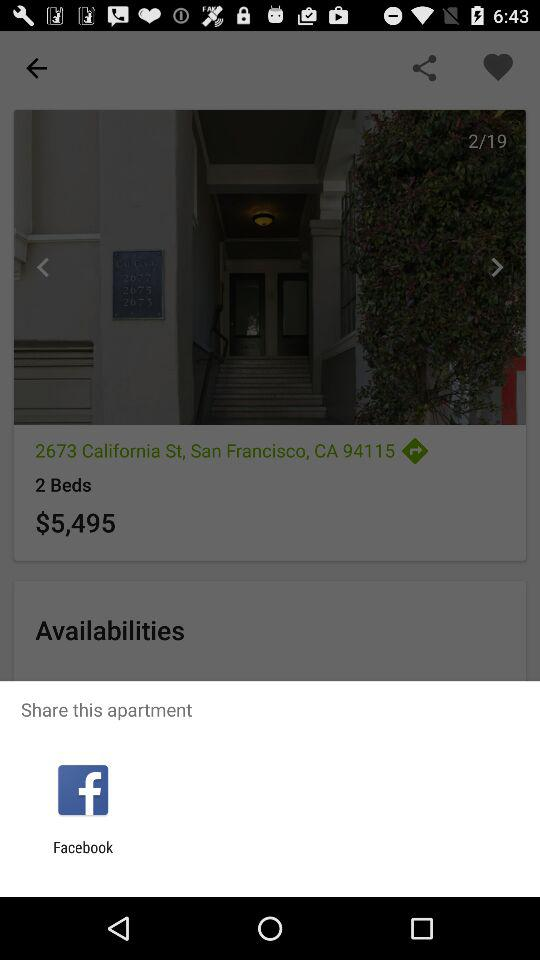What are the charges for the apartment? The charges for the apartment are $5,495. 